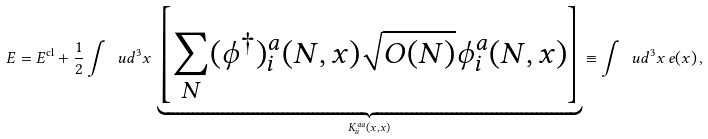<formula> <loc_0><loc_0><loc_500><loc_500>E = E ^ { \text {cl} } + \frac { 1 } { 2 } \int \ u d ^ { 3 } x \, \underbrace { \left [ \sum _ { N } ( \phi ^ { \dagger } ) _ { i } ^ { a } ( N , x ) \sqrt { O ( N ) } \phi _ { i } ^ { a } ( N , x ) \right ] } _ { K ^ { a a } _ { i i } ( x , x ) } \equiv \int \ u d ^ { 3 } x \, e ( x ) \, ,</formula> 